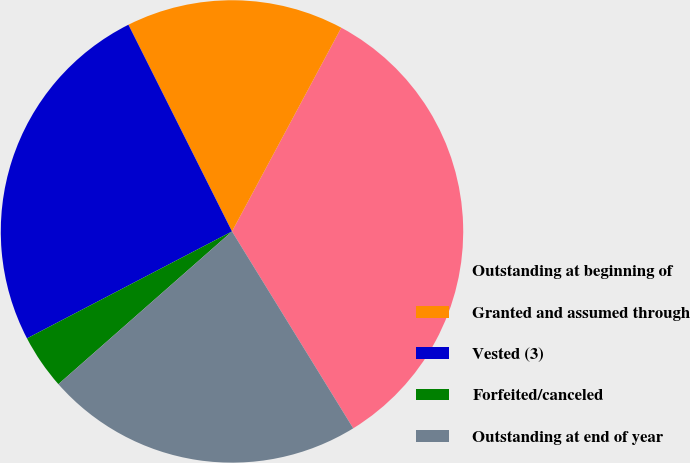Convert chart. <chart><loc_0><loc_0><loc_500><loc_500><pie_chart><fcel>Outstanding at beginning of<fcel>Granted and assumed through<fcel>Vested (3)<fcel>Forfeited/canceled<fcel>Outstanding at end of year<nl><fcel>33.38%<fcel>15.23%<fcel>25.26%<fcel>3.83%<fcel>22.3%<nl></chart> 